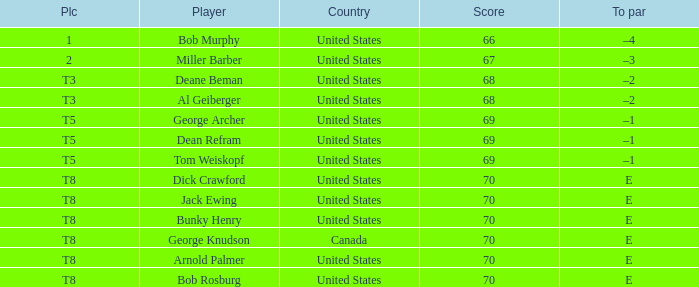When Bunky Henry of the United States scored higher than 68 and his To par was e, what was his place? T8. 